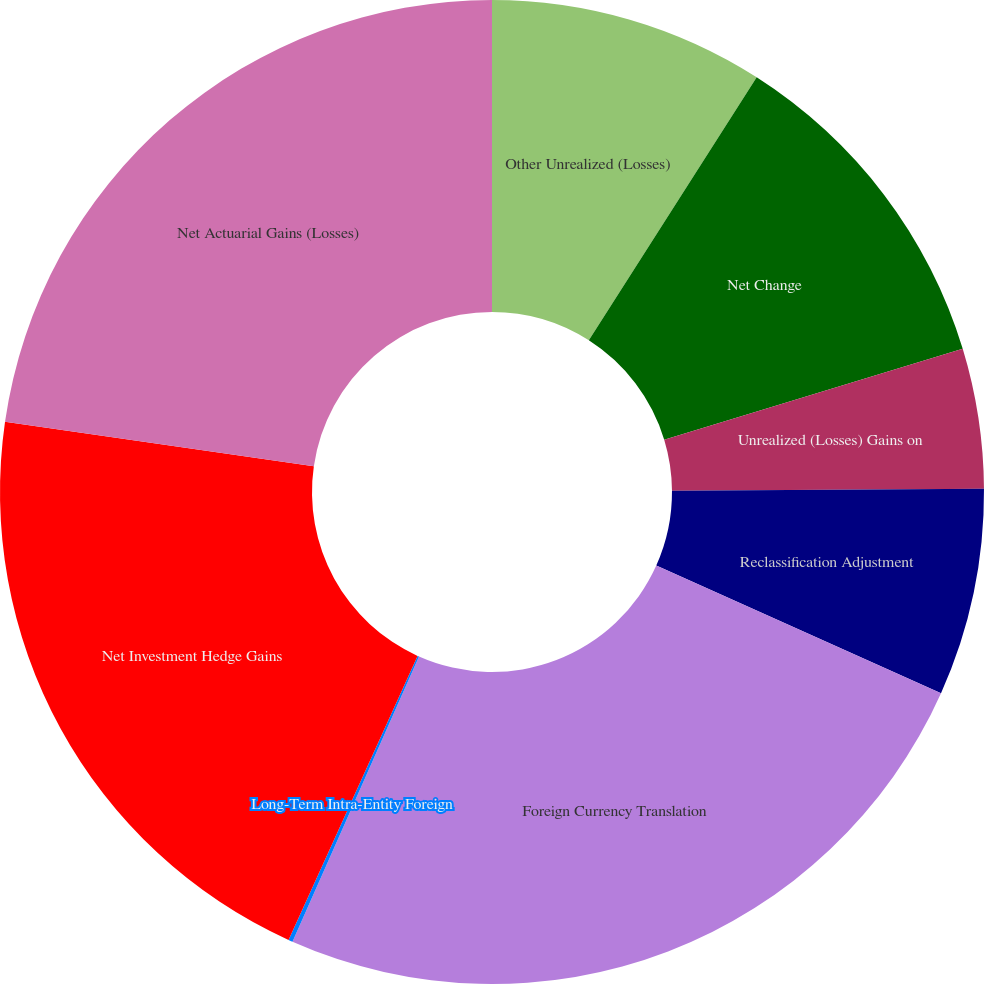Convert chart. <chart><loc_0><loc_0><loc_500><loc_500><pie_chart><fcel>Other Unrealized (Losses)<fcel>Net Change<fcel>Unrealized (Losses) Gains on<fcel>Reclassification Adjustment<fcel>Foreign Currency Translation<fcel>Long-Term Intra-Entity Foreign<fcel>Net Investment Hedge Gains<fcel>Net Actuarial Gains (Losses)<nl><fcel>9.04%<fcel>11.26%<fcel>4.59%<fcel>6.81%<fcel>24.94%<fcel>0.14%<fcel>20.49%<fcel>22.72%<nl></chart> 